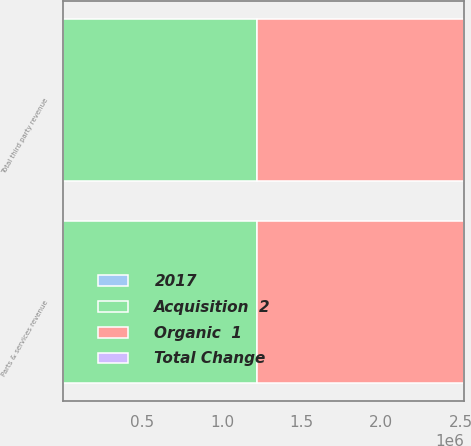<chart> <loc_0><loc_0><loc_500><loc_500><stacked_bar_chart><ecel><fcel>Parts & services revenue<fcel>Total third party revenue<nl><fcel>Organic  1<fcel>1.3012e+06<fcel>1.3012e+06<nl><fcel>Acquisition  2<fcel>1.21968e+06<fcel>1.21968e+06<nl><fcel>2017<fcel>4.7<fcel>4.7<nl><fcel>Total Change<fcel>1.9<fcel>1.9<nl></chart> 